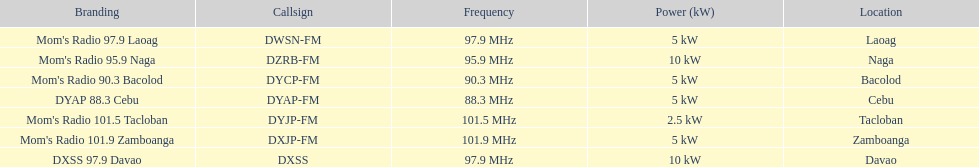What is the count of occurrences where the frequency is above 95? 5. 